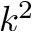<formula> <loc_0><loc_0><loc_500><loc_500>k ^ { 2 }</formula> 